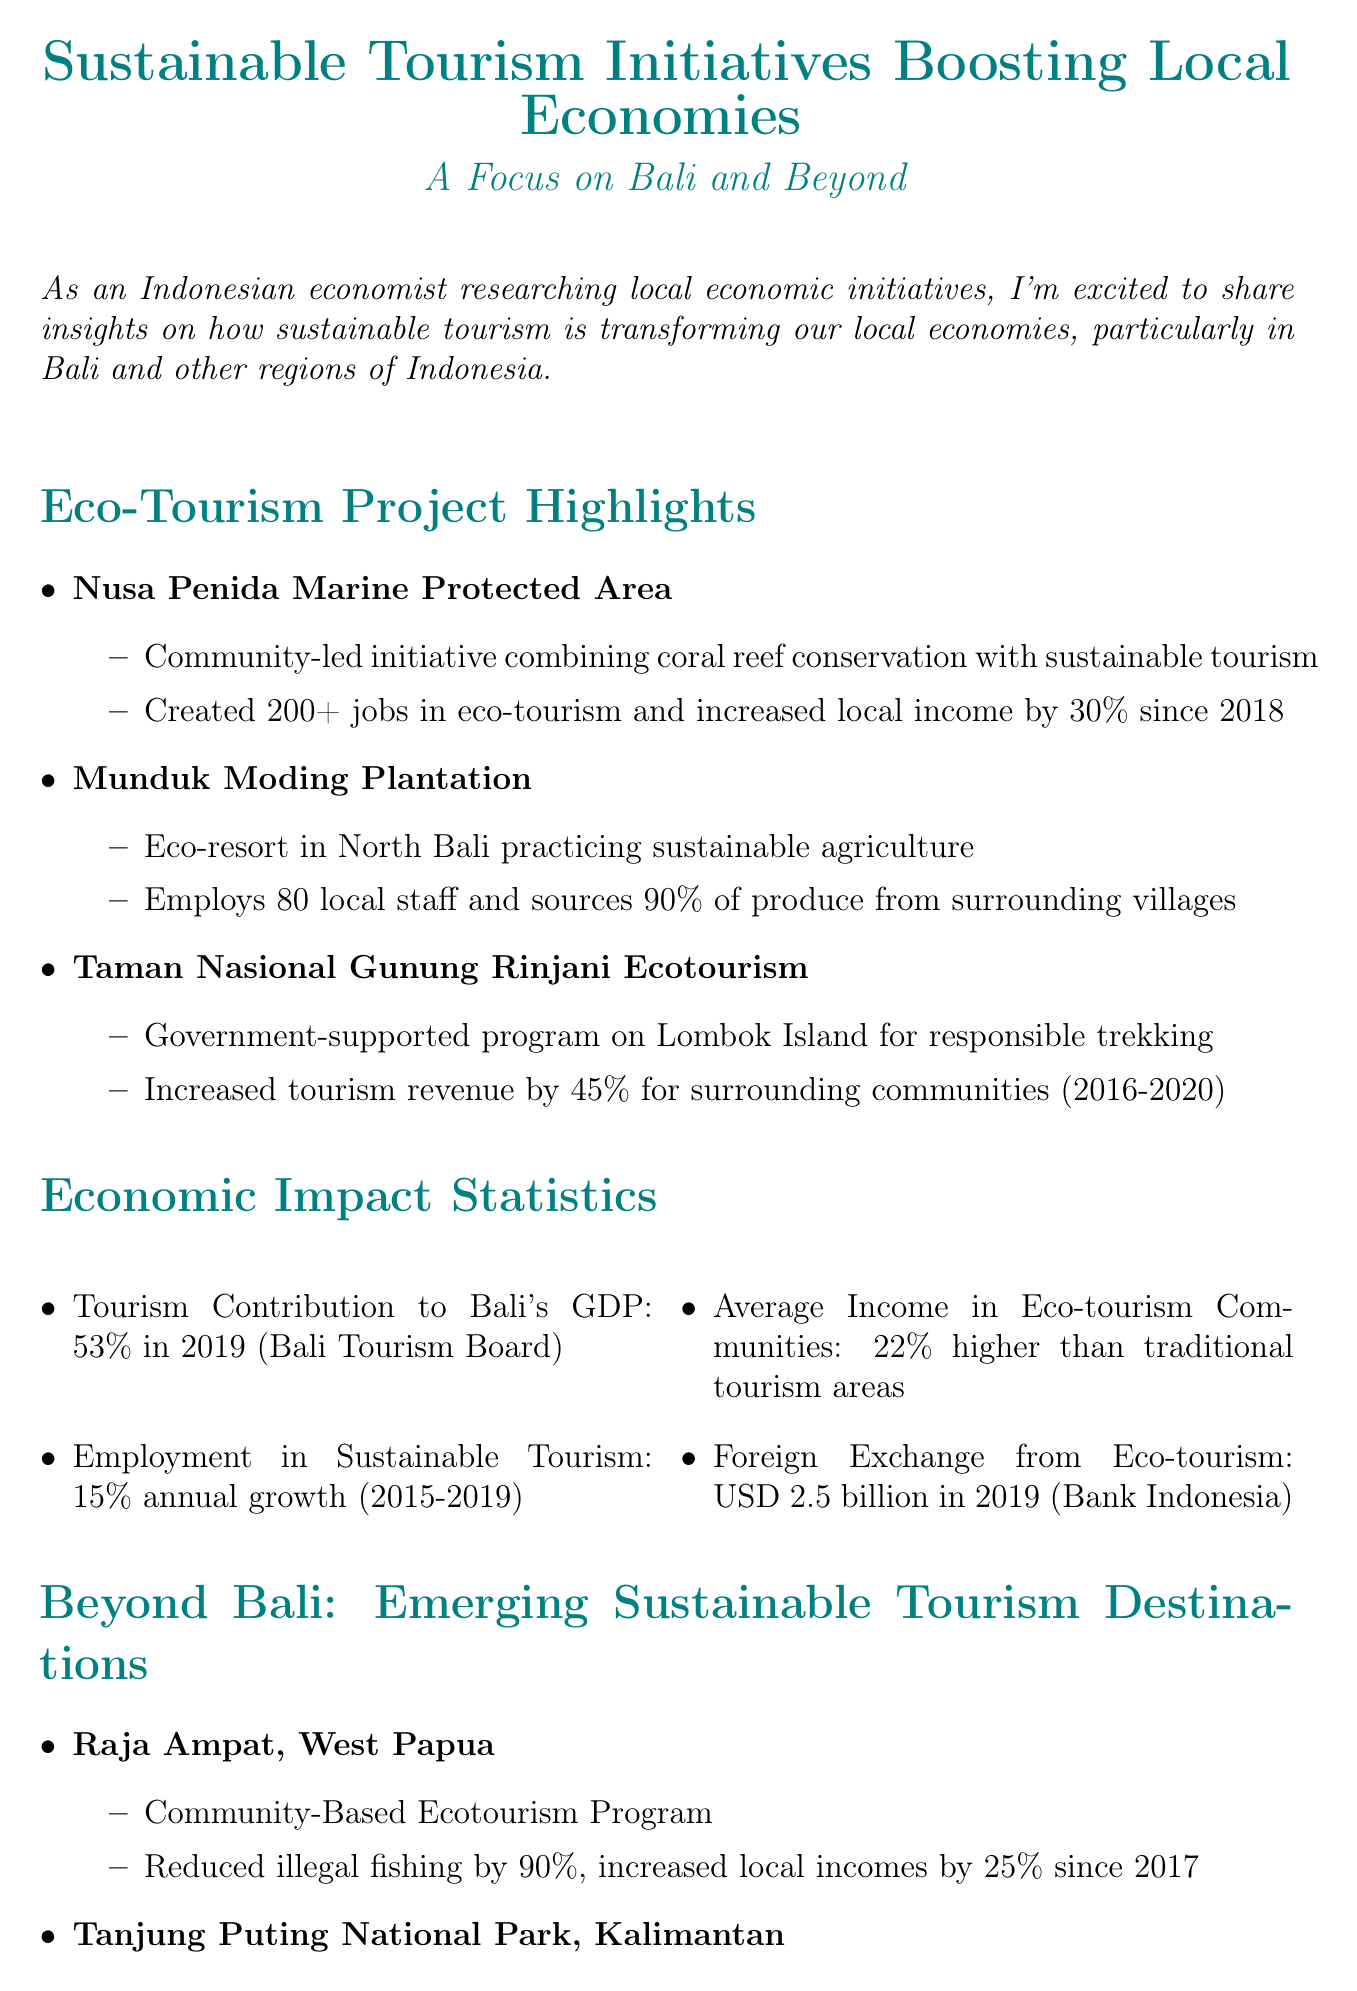What is the title of the newsletter? The title is indicated at the beginning of the document, summarizing the content focus.
Answer: Sustainable Tourism Initiatives Boosting Local Economies: A Focus on Bali and Beyond How many jobs were created by the Nusa Penida Marine Protected Area? The section on Eco-Tourism Project Highlights provides specific data about job creation from this project.
Answer: 200+ What is the average income increase in eco-tourism communities compared to traditional tourism areas? The Economic Impact Statistics section lists this specific statistic for clarity.
Answer: 22% higher Which initiative reduced illegal fishing by 90%? The document specifies the impact of the community-based ecotourism program in a particular region.
Answer: Community-Based Ecotourism Program What was the contribution of tourism to Bali's GDP in 2019? This information appears in the Economic Impact Statistics section, presenting key economic figures.
Answer: 53% What is one challenge mentioned in the document regarding sustainable tourism? The Challenges and Future Outlook section outlines various challenges faced by sustainable tourism initiatives.
Answer: Balancing tourism growth with environmental preservation How much did tourism revenue increase for surrounding communities from the Taman Nasional Gunung Rinjani Ecotourism project? This statistic is explicitly stated in the Eco-Tourism Project Highlights section under this project.
Answer: 45% How many local staff does Munduk Moding Plantation employ? The document provides specific employment statistics related to this eco-resort.
Answer: 80 What is a proposed potential for eco-tourism mentioned in the Challenges and Future Outlook section? The section emphasizes future opportunities for eco-tourism as a recovery strategy post-pandemic.
Answer: Drive Indonesia's post-pandemic economic recovery 